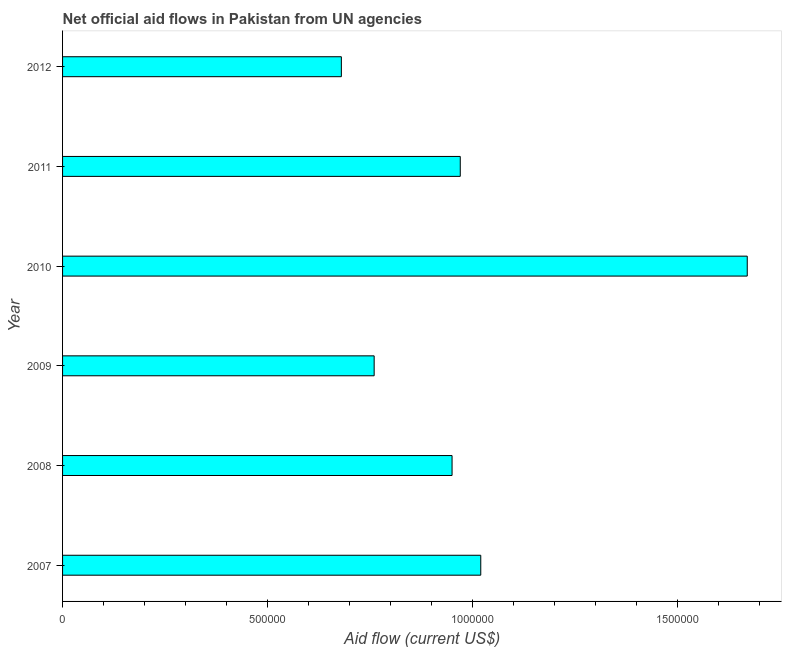Does the graph contain grids?
Keep it short and to the point. No. What is the title of the graph?
Offer a terse response. Net official aid flows in Pakistan from UN agencies. What is the label or title of the Y-axis?
Give a very brief answer. Year. What is the net official flows from un agencies in 2012?
Your answer should be compact. 6.80e+05. Across all years, what is the maximum net official flows from un agencies?
Make the answer very short. 1.67e+06. Across all years, what is the minimum net official flows from un agencies?
Your answer should be compact. 6.80e+05. In which year was the net official flows from un agencies maximum?
Ensure brevity in your answer.  2010. In which year was the net official flows from un agencies minimum?
Your answer should be compact. 2012. What is the sum of the net official flows from un agencies?
Ensure brevity in your answer.  6.05e+06. What is the difference between the net official flows from un agencies in 2007 and 2011?
Your answer should be very brief. 5.00e+04. What is the average net official flows from un agencies per year?
Provide a succinct answer. 1.01e+06. What is the median net official flows from un agencies?
Provide a short and direct response. 9.60e+05. In how many years, is the net official flows from un agencies greater than 400000 US$?
Your response must be concise. 6. What is the ratio of the net official flows from un agencies in 2008 to that in 2011?
Offer a very short reply. 0.98. What is the difference between the highest and the second highest net official flows from un agencies?
Offer a terse response. 6.50e+05. What is the difference between the highest and the lowest net official flows from un agencies?
Your response must be concise. 9.90e+05. In how many years, is the net official flows from un agencies greater than the average net official flows from un agencies taken over all years?
Make the answer very short. 2. How many bars are there?
Keep it short and to the point. 6. Are all the bars in the graph horizontal?
Your answer should be compact. Yes. How many years are there in the graph?
Make the answer very short. 6. Are the values on the major ticks of X-axis written in scientific E-notation?
Provide a short and direct response. No. What is the Aid flow (current US$) in 2007?
Offer a very short reply. 1.02e+06. What is the Aid flow (current US$) in 2008?
Ensure brevity in your answer.  9.50e+05. What is the Aid flow (current US$) of 2009?
Ensure brevity in your answer.  7.60e+05. What is the Aid flow (current US$) in 2010?
Offer a very short reply. 1.67e+06. What is the Aid flow (current US$) of 2011?
Make the answer very short. 9.70e+05. What is the Aid flow (current US$) in 2012?
Your answer should be compact. 6.80e+05. What is the difference between the Aid flow (current US$) in 2007 and 2008?
Provide a short and direct response. 7.00e+04. What is the difference between the Aid flow (current US$) in 2007 and 2010?
Your response must be concise. -6.50e+05. What is the difference between the Aid flow (current US$) in 2007 and 2011?
Keep it short and to the point. 5.00e+04. What is the difference between the Aid flow (current US$) in 2008 and 2010?
Provide a short and direct response. -7.20e+05. What is the difference between the Aid flow (current US$) in 2008 and 2011?
Make the answer very short. -2.00e+04. What is the difference between the Aid flow (current US$) in 2008 and 2012?
Provide a short and direct response. 2.70e+05. What is the difference between the Aid flow (current US$) in 2009 and 2010?
Provide a succinct answer. -9.10e+05. What is the difference between the Aid flow (current US$) in 2009 and 2011?
Give a very brief answer. -2.10e+05. What is the difference between the Aid flow (current US$) in 2009 and 2012?
Offer a terse response. 8.00e+04. What is the difference between the Aid flow (current US$) in 2010 and 2011?
Your response must be concise. 7.00e+05. What is the difference between the Aid flow (current US$) in 2010 and 2012?
Give a very brief answer. 9.90e+05. What is the difference between the Aid flow (current US$) in 2011 and 2012?
Your answer should be very brief. 2.90e+05. What is the ratio of the Aid flow (current US$) in 2007 to that in 2008?
Give a very brief answer. 1.07. What is the ratio of the Aid flow (current US$) in 2007 to that in 2009?
Ensure brevity in your answer.  1.34. What is the ratio of the Aid flow (current US$) in 2007 to that in 2010?
Provide a short and direct response. 0.61. What is the ratio of the Aid flow (current US$) in 2007 to that in 2011?
Your response must be concise. 1.05. What is the ratio of the Aid flow (current US$) in 2008 to that in 2010?
Ensure brevity in your answer.  0.57. What is the ratio of the Aid flow (current US$) in 2008 to that in 2011?
Offer a very short reply. 0.98. What is the ratio of the Aid flow (current US$) in 2008 to that in 2012?
Provide a succinct answer. 1.4. What is the ratio of the Aid flow (current US$) in 2009 to that in 2010?
Give a very brief answer. 0.46. What is the ratio of the Aid flow (current US$) in 2009 to that in 2011?
Offer a terse response. 0.78. What is the ratio of the Aid flow (current US$) in 2009 to that in 2012?
Your answer should be very brief. 1.12. What is the ratio of the Aid flow (current US$) in 2010 to that in 2011?
Make the answer very short. 1.72. What is the ratio of the Aid flow (current US$) in 2010 to that in 2012?
Provide a short and direct response. 2.46. What is the ratio of the Aid flow (current US$) in 2011 to that in 2012?
Offer a terse response. 1.43. 